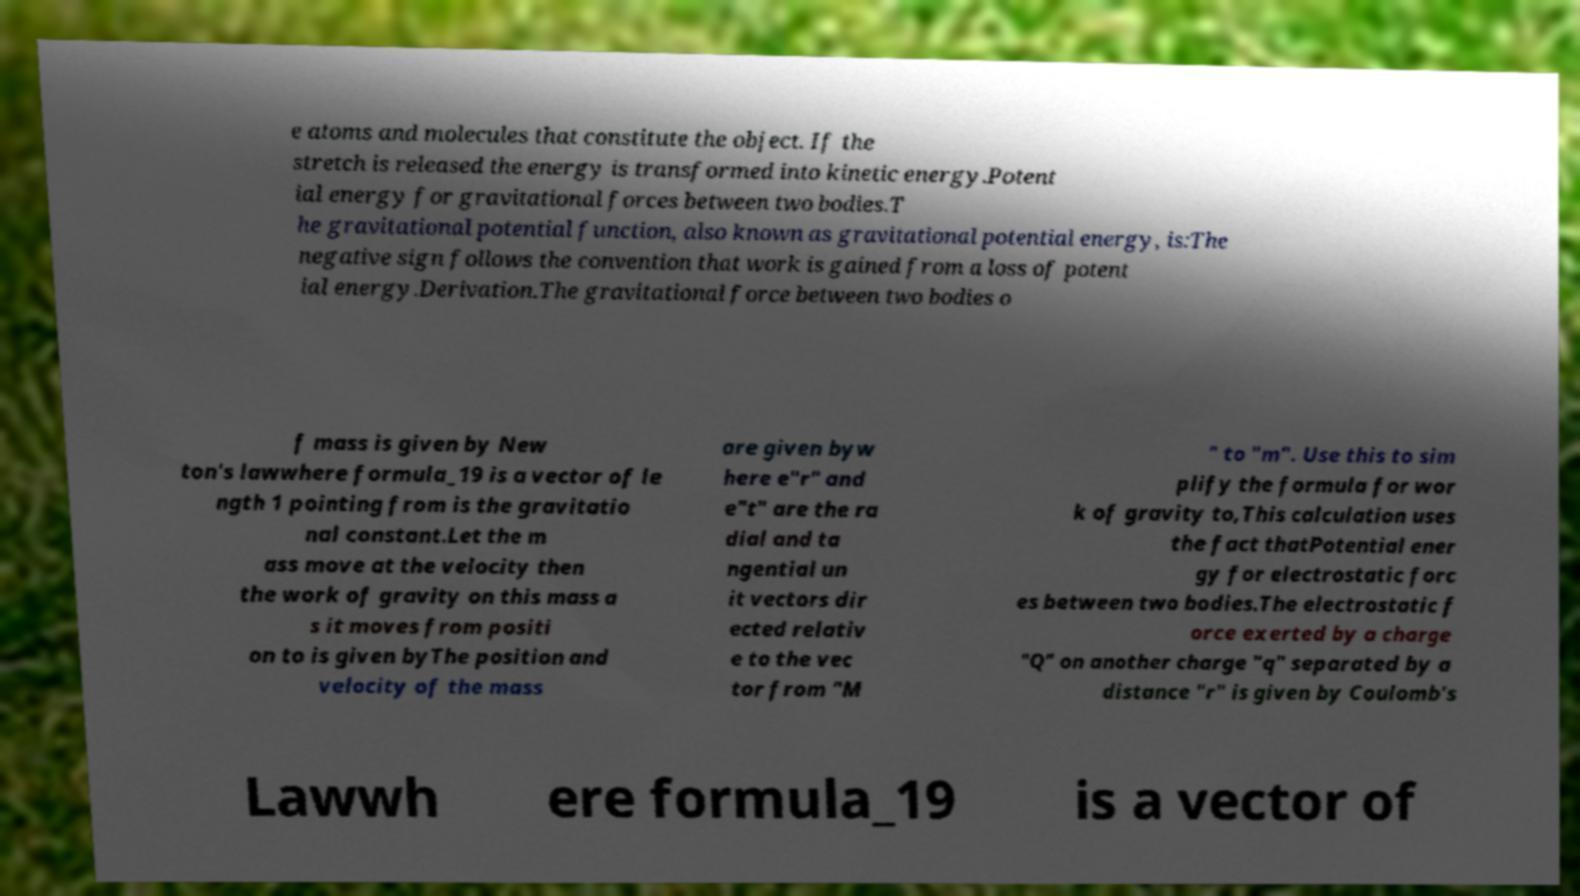Please read and relay the text visible in this image. What does it say? e atoms and molecules that constitute the object. If the stretch is released the energy is transformed into kinetic energy.Potent ial energy for gravitational forces between two bodies.T he gravitational potential function, also known as gravitational potential energy, is:The negative sign follows the convention that work is gained from a loss of potent ial energy.Derivation.The gravitational force between two bodies o f mass is given by New ton's lawwhere formula_19 is a vector of le ngth 1 pointing from is the gravitatio nal constant.Let the m ass move at the velocity then the work of gravity on this mass a s it moves from positi on to is given byThe position and velocity of the mass are given byw here e"r" and e"t" are the ra dial and ta ngential un it vectors dir ected relativ e to the vec tor from "M " to "m". Use this to sim plify the formula for wor k of gravity to,This calculation uses the fact thatPotential ener gy for electrostatic forc es between two bodies.The electrostatic f orce exerted by a charge "Q" on another charge "q" separated by a distance "r" is given by Coulomb's Lawwh ere formula_19 is a vector of 